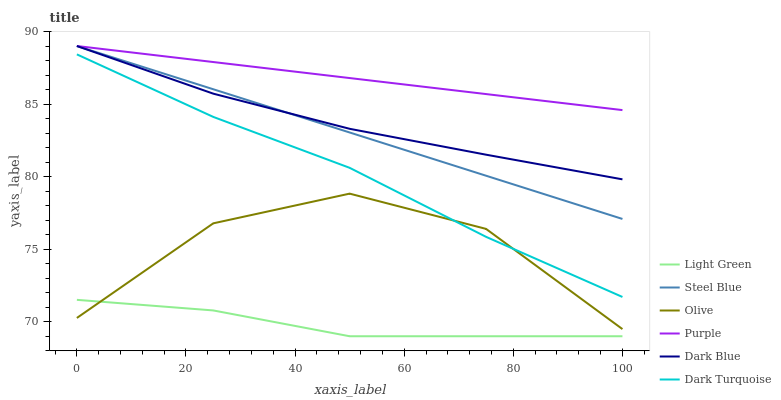Does Light Green have the minimum area under the curve?
Answer yes or no. Yes. Does Purple have the maximum area under the curve?
Answer yes or no. Yes. Does Dark Turquoise have the minimum area under the curve?
Answer yes or no. No. Does Dark Turquoise have the maximum area under the curve?
Answer yes or no. No. Is Steel Blue the smoothest?
Answer yes or no. Yes. Is Olive the roughest?
Answer yes or no. Yes. Is Dark Turquoise the smoothest?
Answer yes or no. No. Is Dark Turquoise the roughest?
Answer yes or no. No. Does Dark Turquoise have the lowest value?
Answer yes or no. No. Does Dark Turquoise have the highest value?
Answer yes or no. No. Is Light Green less than Dark Blue?
Answer yes or no. Yes. Is Dark Turquoise greater than Light Green?
Answer yes or no. Yes. Does Light Green intersect Dark Blue?
Answer yes or no. No. 